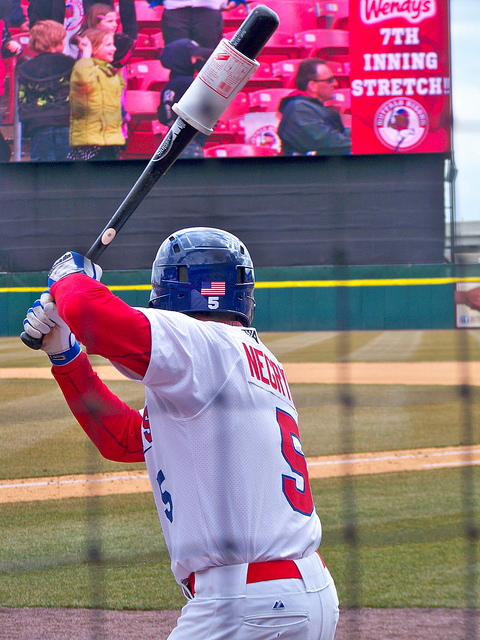Please transcribe the text information in this image. WENAYS 7TH INNING STRETCH 5 S 5 9 NEGRT 